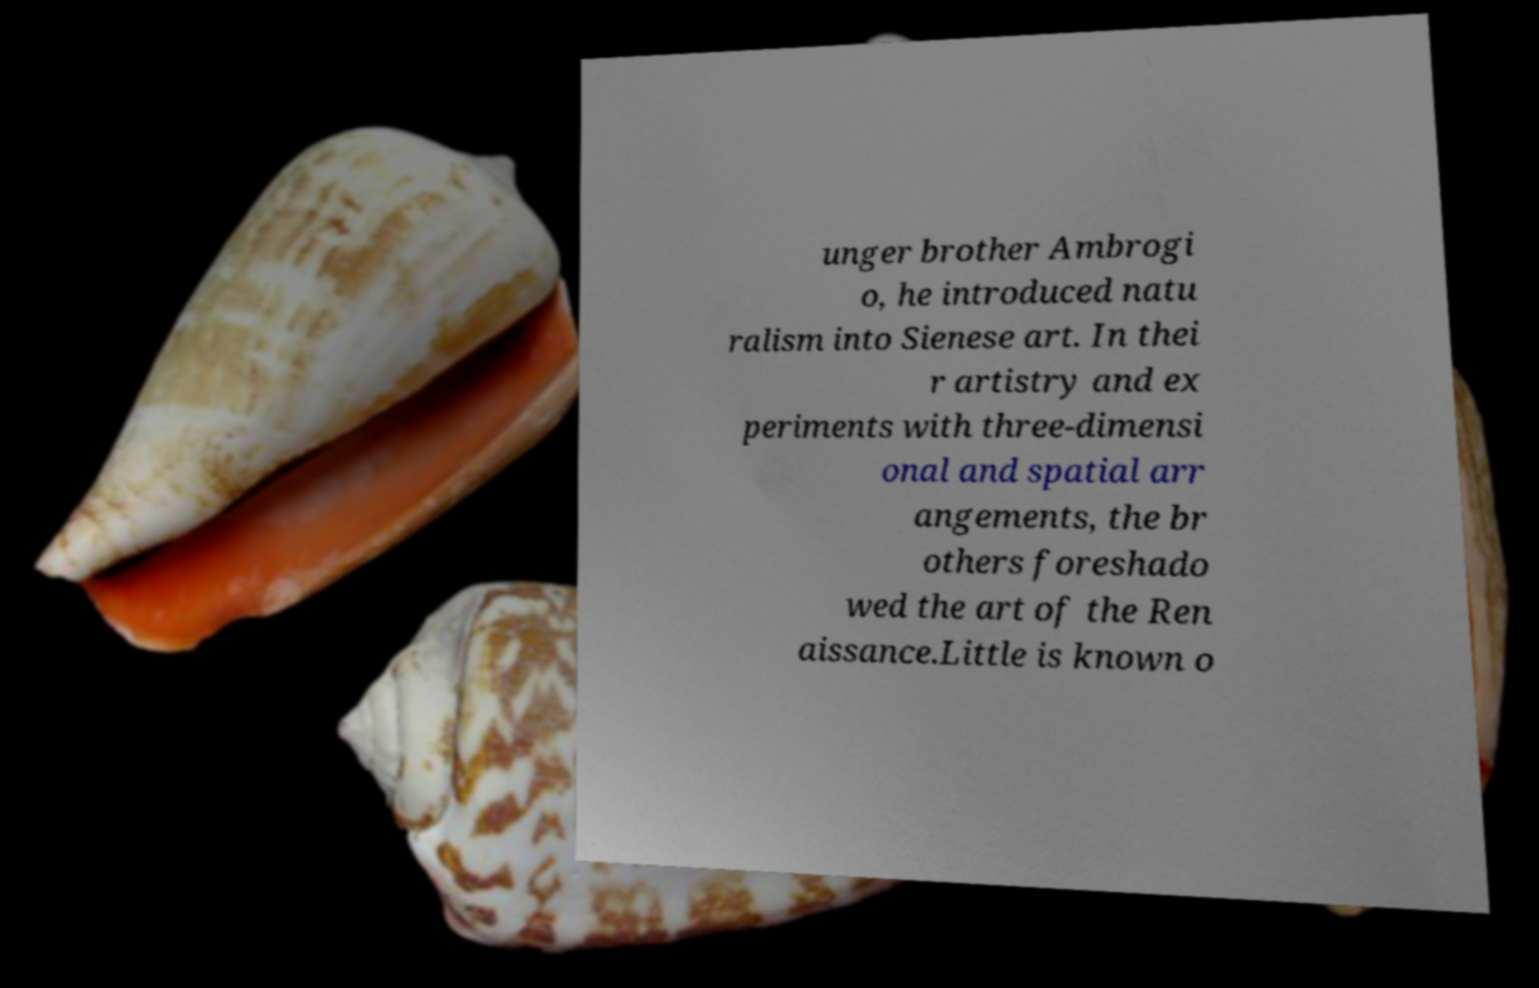There's text embedded in this image that I need extracted. Can you transcribe it verbatim? unger brother Ambrogi o, he introduced natu ralism into Sienese art. In thei r artistry and ex periments with three-dimensi onal and spatial arr angements, the br others foreshado wed the art of the Ren aissance.Little is known o 